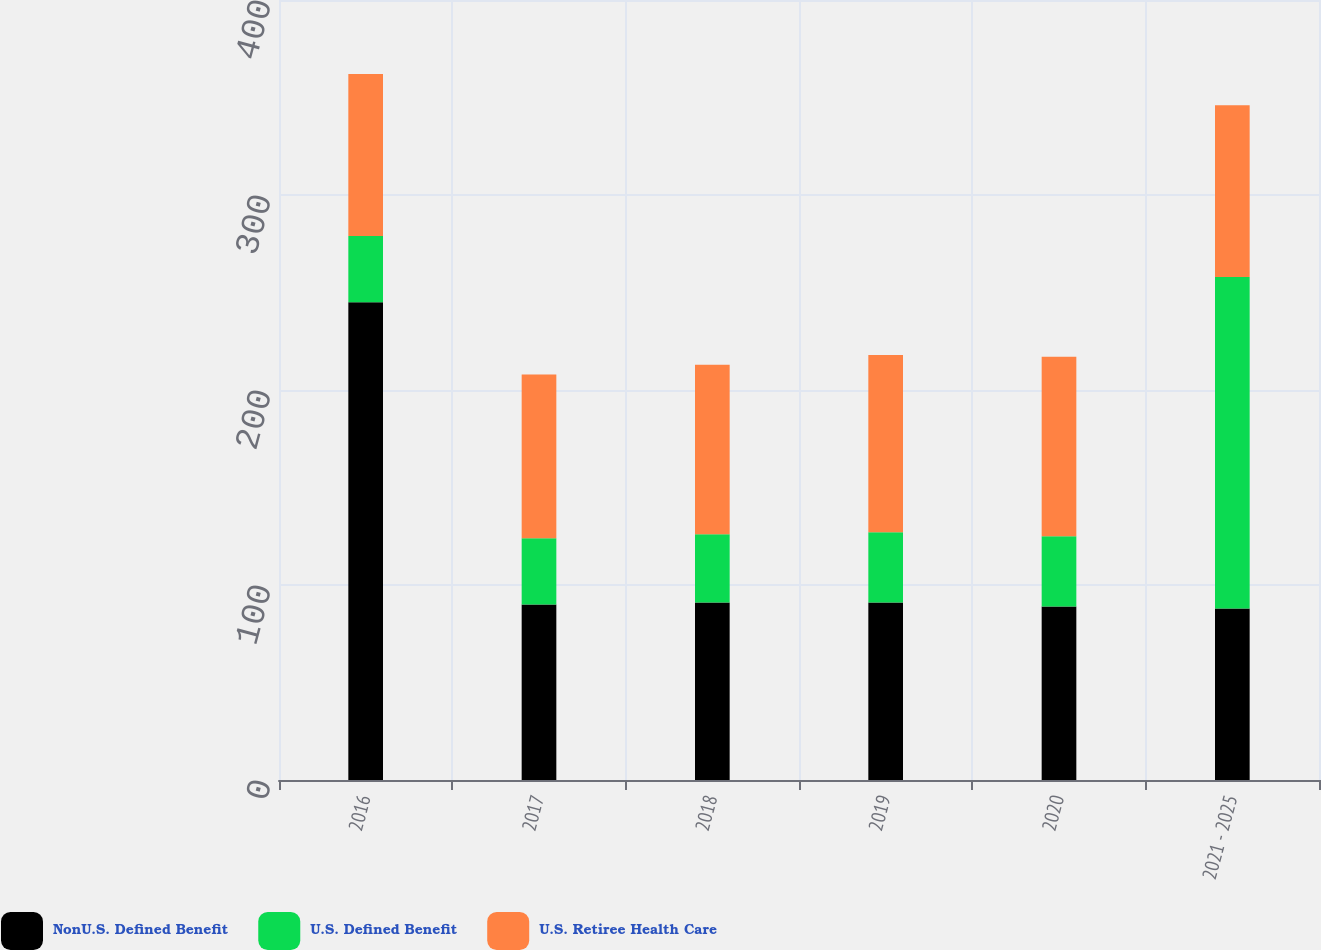<chart> <loc_0><loc_0><loc_500><loc_500><stacked_bar_chart><ecel><fcel>2016<fcel>2017<fcel>2018<fcel>2019<fcel>2020<fcel>2021 - 2025<nl><fcel>NonU.S. Defined Benefit<fcel>245<fcel>90<fcel>91<fcel>91<fcel>89<fcel>88<nl><fcel>U.S. Defined Benefit<fcel>34<fcel>34<fcel>35<fcel>36<fcel>36<fcel>170<nl><fcel>U.S. Retiree Health Care<fcel>83<fcel>84<fcel>87<fcel>91<fcel>92<fcel>88<nl></chart> 